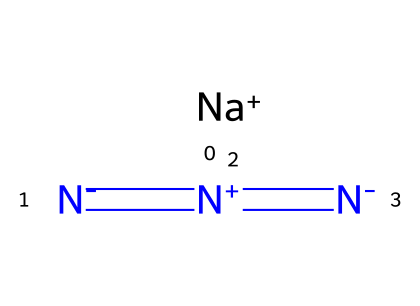What is the formula for sodium azide? The SMILES representation indicates the sodium ion ([Na+]) and the azide ion ([N-]=[N+]=[N-]), so combining these gives the formula NaN3.
Answer: NaN3 How many nitrogen atoms are in sodium azide? The structure shows that there are three nitrogen atoms in the azide group.
Answer: 3 What ion is present with sodium azide? The sodium azide consists of a sodium cation represented as [Na+].
Answer: sodium ion What type of bond connects the nitrogen atoms in sodium azide? The nitrogen atoms are connected by double bonds as shown in the SMILES, indicated by the "=" signs.
Answer: double bonds What is the charge of the azide ion in sodium azide? The azide group overall has a negative charge, which is indicated by the presence of three nitrogen atoms with formal charges.
Answer: -1 What makes sodium azide a good laboratory reagent? Sodium azide is a common laboratory reagent due to its stability, the presence of the azide functional group, and reactivity in converting to a nitride or during click chemistry reactions.
Answer: stability and reactivity How can sodium azide be hazardous? Sodium azide is hazardous due to its ability to release toxic gases upon decomposition, such as nitrogen gas and potentially explosive properties.
Answer: toxic and explosive 